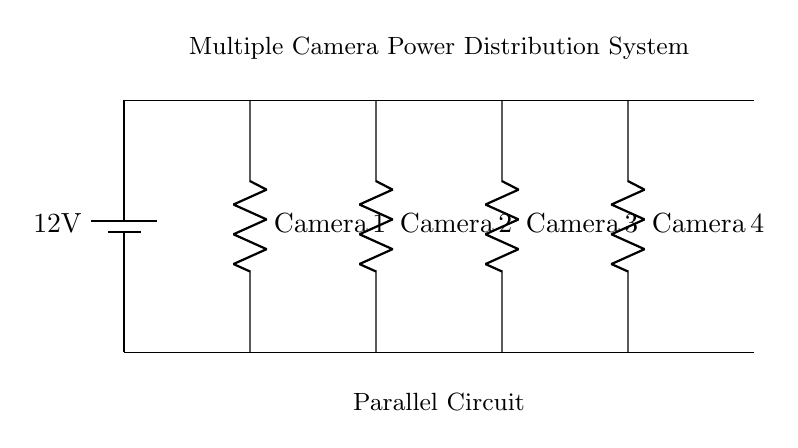What is the voltage of the power source? The voltage is given as 12V, which is indicated next to the battery in the diagram.
Answer: 12 volts How many cameras are connected in the system? There are four cameras shown in the diagram, as represented by the four resistors labeled Camera 1, Camera 2, Camera 3, and Camera 4.
Answer: Four What type of circuit is used for the cameras? The circuit shown is a parallel circuit, where each camera is connected across the same voltage source, allowing them to operate independently.
Answer: Parallel What is the role of the main distribution line? The main distribution line provides a common connection for all the cameras to the power source, ensuring they all receive the same voltage.
Answer: Common connection If one camera fails, what happens to the others? In a parallel circuit, the failure of one component (camera) does not affect the operation of the other components because they have independent paths to the power source.
Answer: Other cameras continue working What happens to the total current when more cameras are added? When more cameras are added in a parallel circuit, the total current increases because each added camera provides an additional path for the current to flow.
Answer: Total current increases 